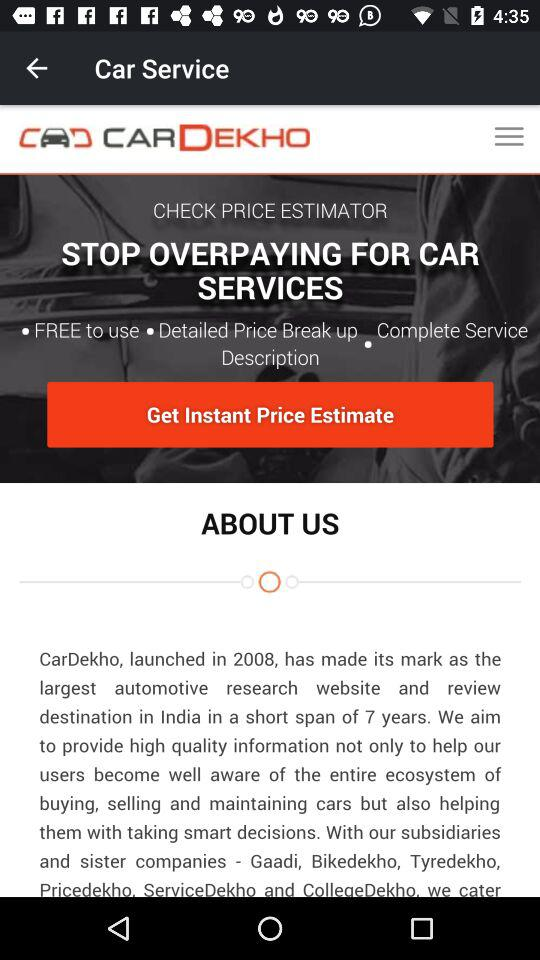What is the name of the application? The name of the application is "CARDEKHO". 